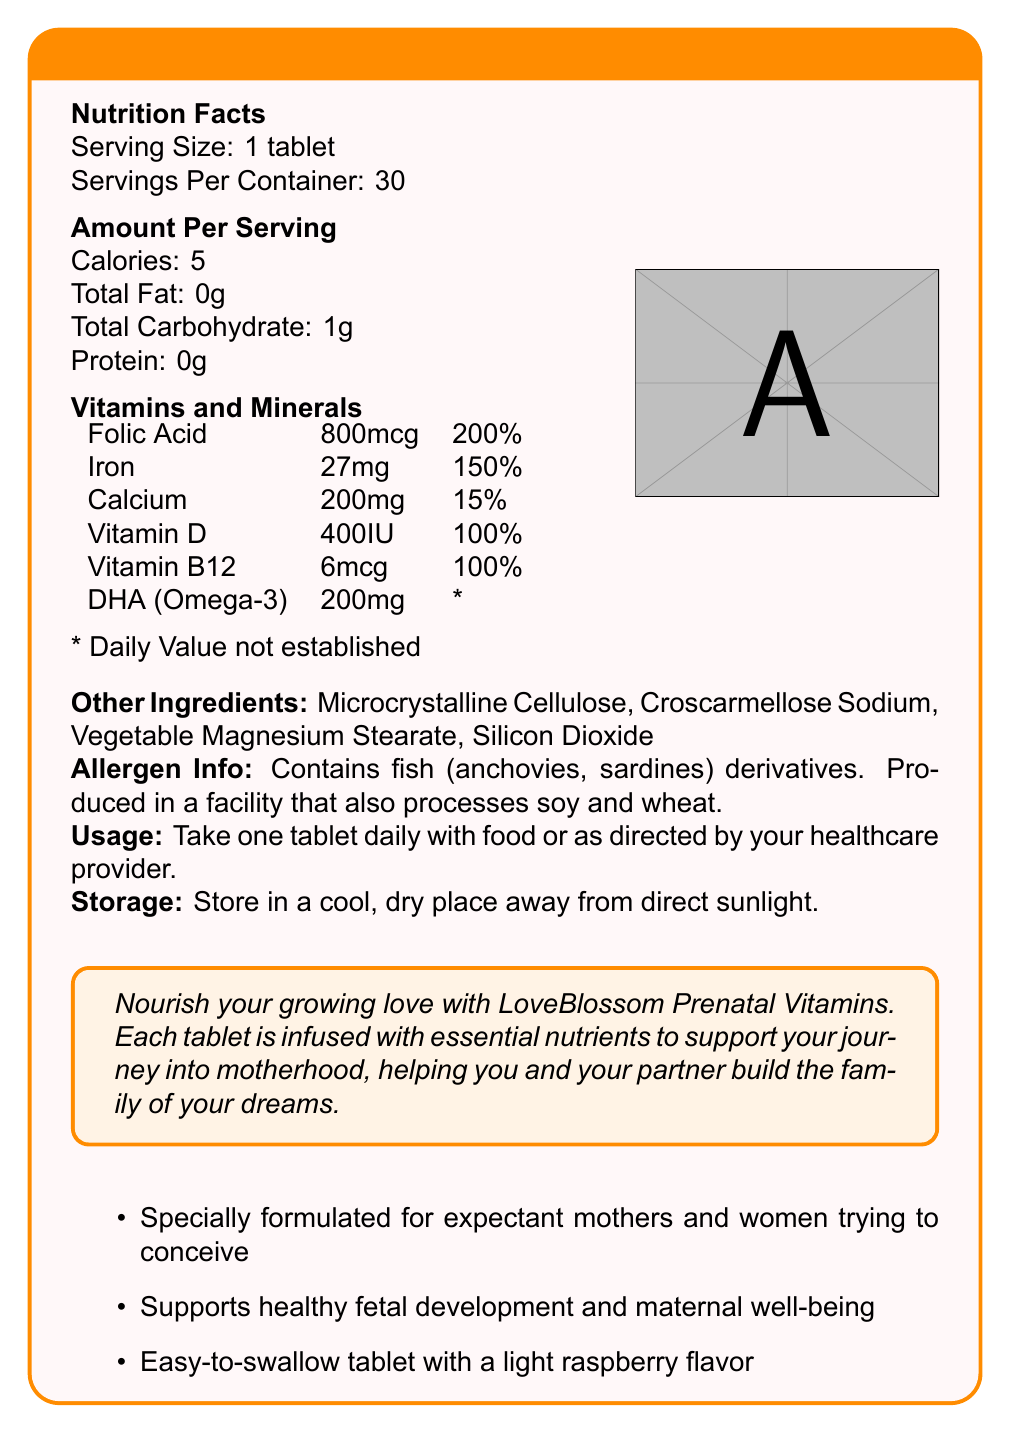what is the product name? The product name is clearly stated at the top of the document.
Answer: LoveBlossom Prenatal Vitamins what is the serving size for LoveBlossom Prenatal Vitamins? The serving size is listed as "1 tablet" under the Nutrition Facts section.
Answer: 1 tablet how many servings are in one container of LoveBlossom Prenatal Vitamins? The document mentions that there are 30 servings per container.
Answer: 30 what is the daily value percentage of Folic Acid in LoveBlossom Prenatal Vitamins? The daily value percentage for Folic Acid is listed as 200% in the Vitamins and Minerals section.
Answer: 200% name two other ingredients in LoveBlossom Prenatal Vitamins not listed under vitamins and minerals These are listed under the Other Ingredients section in the document.
Answer: Microcrystalline Cellulose, Croscarmellose Sodium which of the following nutrients is NOT included in LoveBlossom Prenatal Vitamins? A. Folic Acid B. Vitamin C C. Iron Vitamin C is not listed as one of the vitamins and minerals in LoveBlossom Prenatal Vitamins.
Answer: B for what specific group is LoveBlossom Prenatal Vitamins specially formulated? A. Athletes B. Children C. Expectant mothers and women trying to conceive D. Seniors The document states that the vitamins are specially formulated for "expectant mothers and women trying to conceive."
Answer: C does LoveBlossom Prenatal Vitamins contain any allergens? The document states that it contains fish (anchovies, sardines) derivatives.
Answer: Yes describe the main idea of the document The document's main focus is to inform potential users about the product’s contents, benefits, and recommended usage, highlighting its purpose for women during pregnancy or those planning to conceive.
Answer: The document provides detailed information about LoveBlossom Prenatal Vitamins, including nutritional content, serving size, ingredients, allergen information, and usage instructions. It emphasizes that the vitamins are specially formulated to support expectant mothers and women trying to conceive. what is the light flavor of the LoveBlossom Prenatal Vitamins tablet? The document mentions that the tablet has a light raspberry flavor.
Answer: Raspberry can we find the price of LoveBlossom Prenatal Vitamins in the document? The document does not provide any information about the price of the product.
Answer: Not enough information what is the recommended way to take LoveBlossom Prenatal Vitamins? The usage instructions are clearly stated in the document.
Answer: Take one tablet daily with food or as directed by your healthcare provider. 